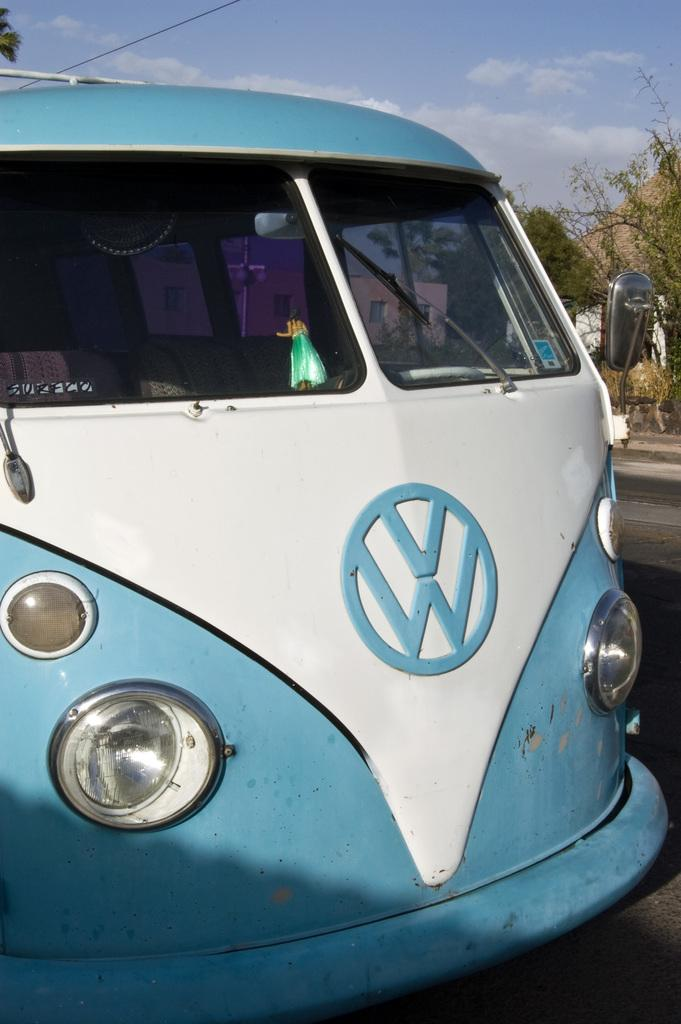<image>
Render a clear and concise summary of the photo. A light blue and white vehicle has the letters VW on the front under the windshield. 